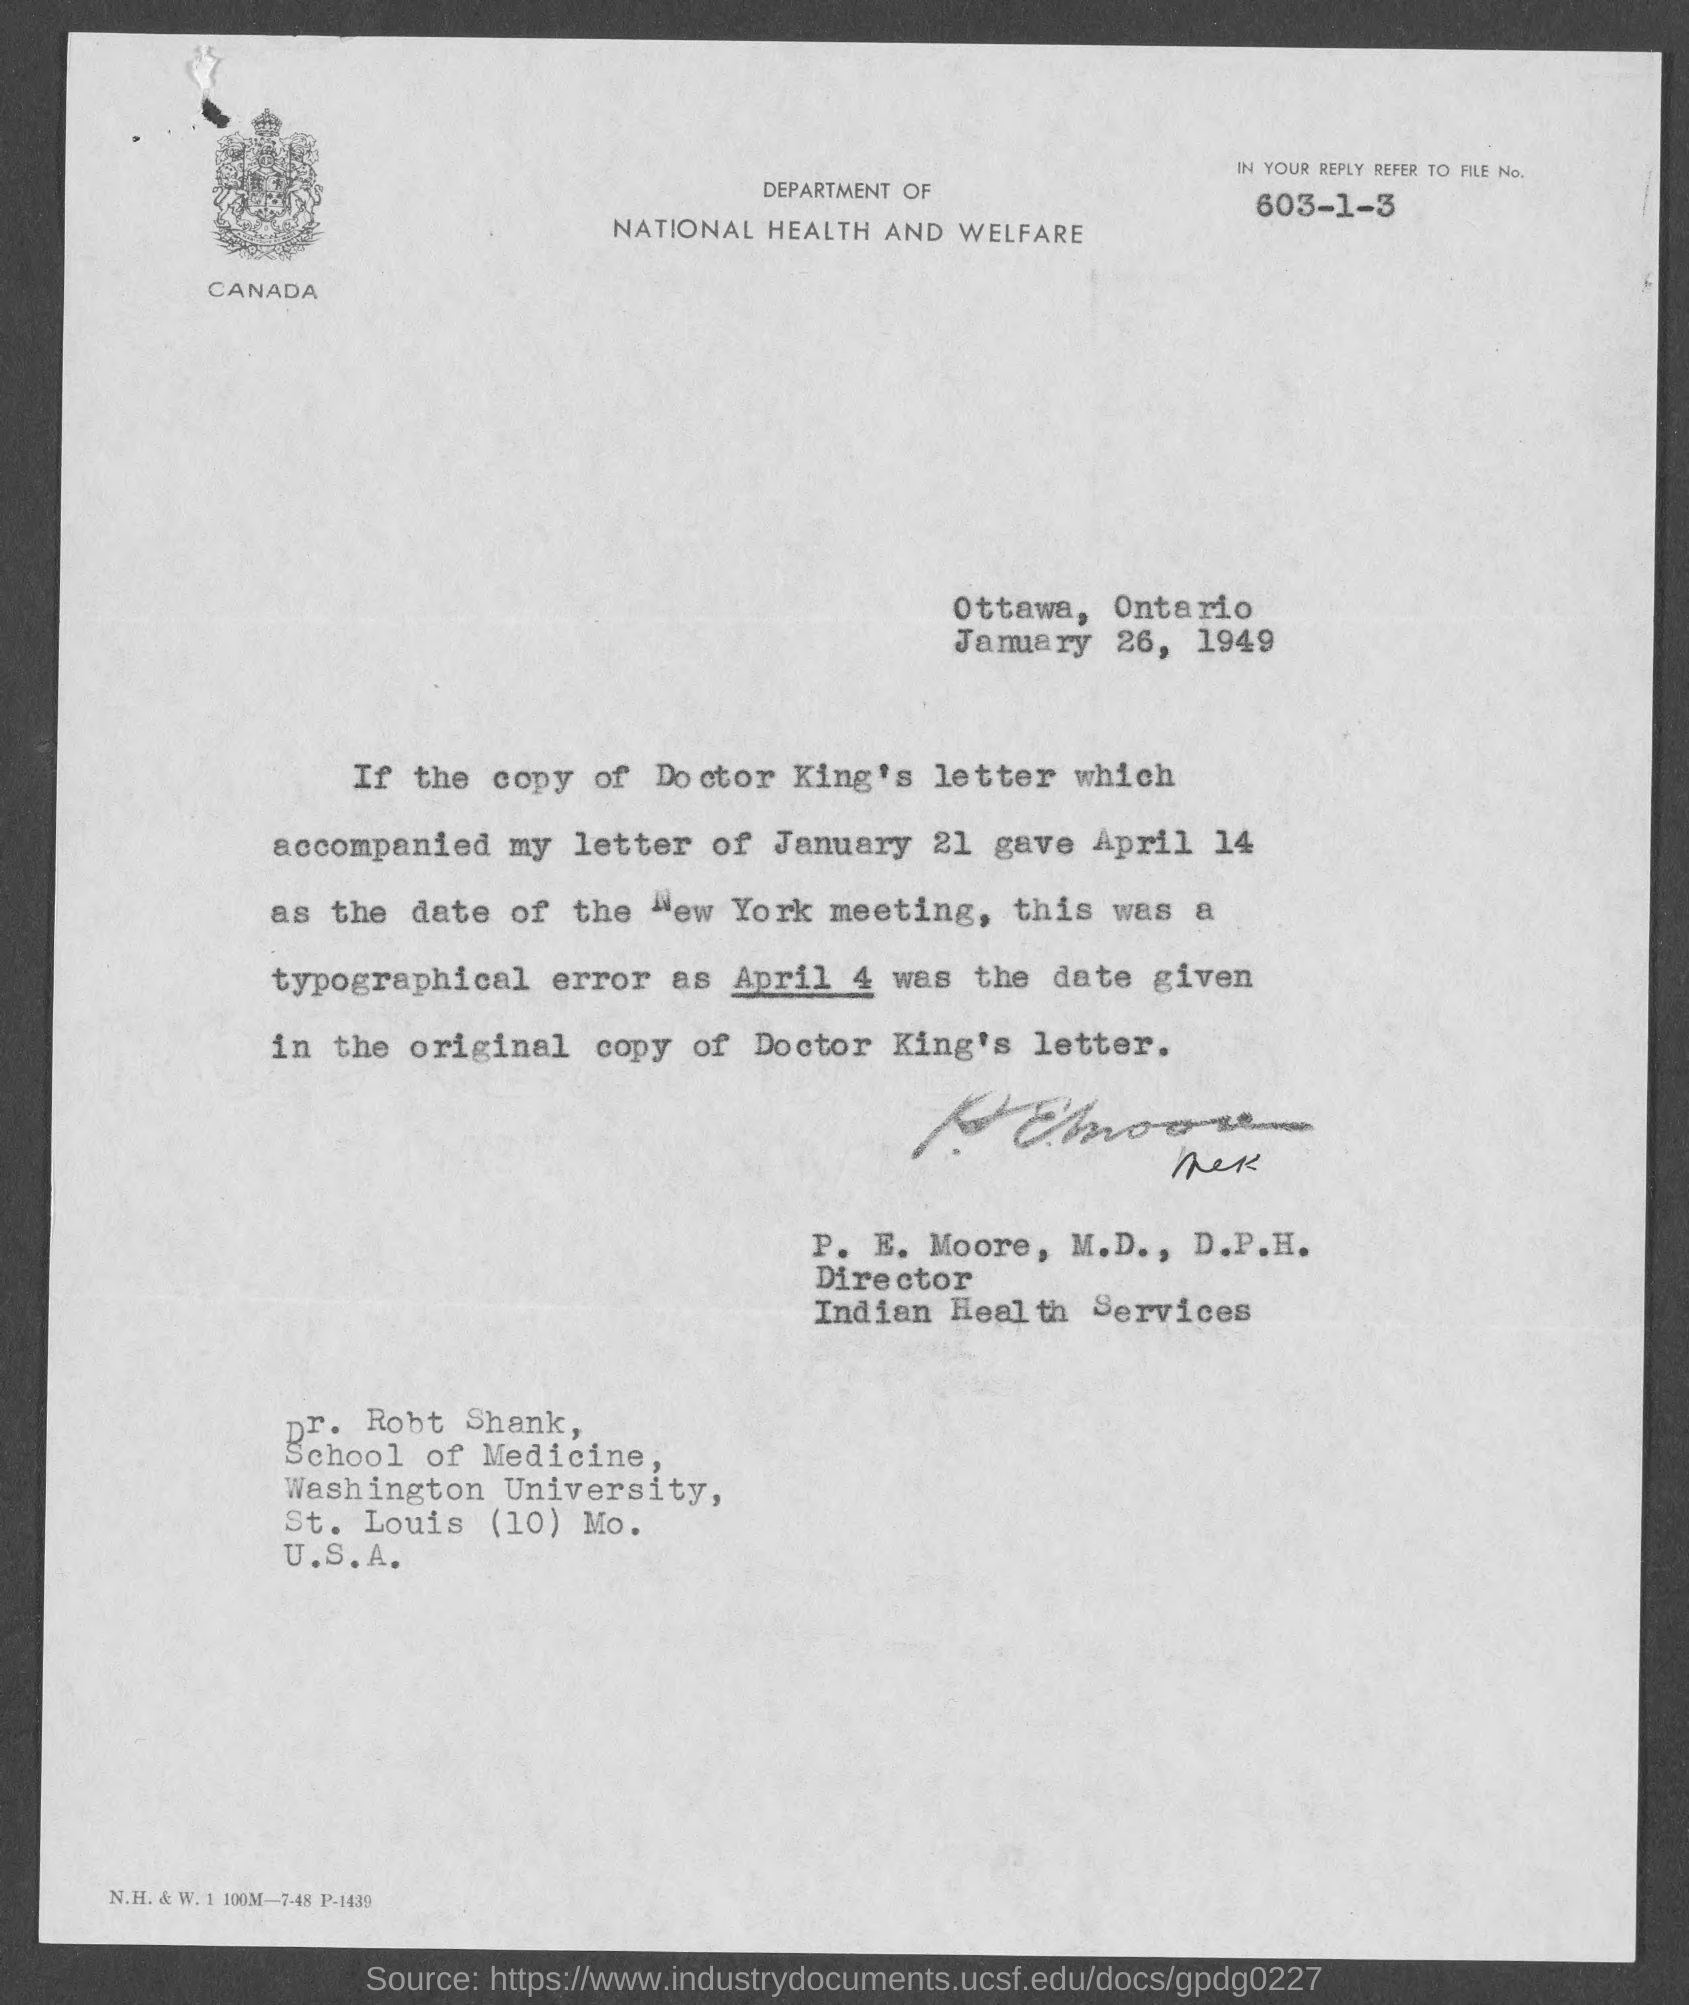Who is the director of indian health services?
Keep it short and to the point. P. E. Moore, M.D., D.P.H. What is place from which letter is written from?
Give a very brief answer. Ottawa, Ontario. On which date the letter is dated on?
Your answer should be compact. January 26, 1949. What is file no. that has to be referred to?
Your answer should be compact. 603-1-3. 